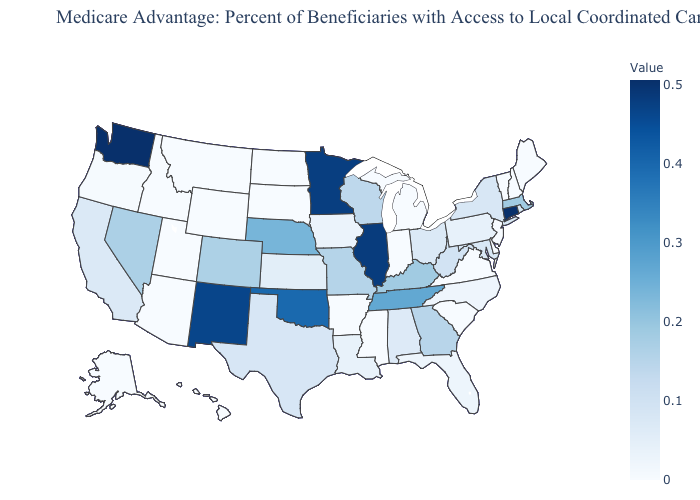Which states have the highest value in the USA?
Short answer required. Washington. Does Illinois have the highest value in the MidWest?
Give a very brief answer. Yes. Among the states that border Michigan , which have the lowest value?
Short answer required. Indiana. Does Indiana have a lower value than Rhode Island?
Write a very short answer. Yes. Which states have the lowest value in the Northeast?
Write a very short answer. Maine, New Hampshire, New Jersey, Vermont. Does Washington have the highest value in the USA?
Short answer required. Yes. Does Ohio have a lower value than Arizona?
Write a very short answer. No. Does Ohio have a lower value than Tennessee?
Short answer required. Yes. Does Maine have the highest value in the USA?
Quick response, please. No. 